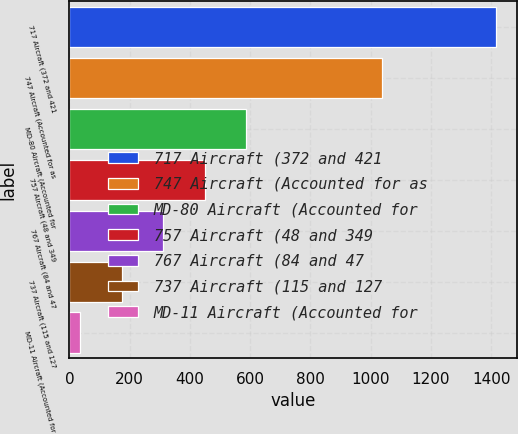Convert chart to OTSL. <chart><loc_0><loc_0><loc_500><loc_500><bar_chart><fcel>717 Aircraft (372 and 421<fcel>747 Aircraft (Accounted for as<fcel>MD-80 Aircraft (Accounted for<fcel>757 Aircraft (48 and 349<fcel>767 Aircraft (84 and 47<fcel>737 Aircraft (115 and 127<fcel>MD-11 Aircraft (Accounted for<nl><fcel>1415<fcel>1038<fcel>587<fcel>449<fcel>311<fcel>173<fcel>35<nl></chart> 